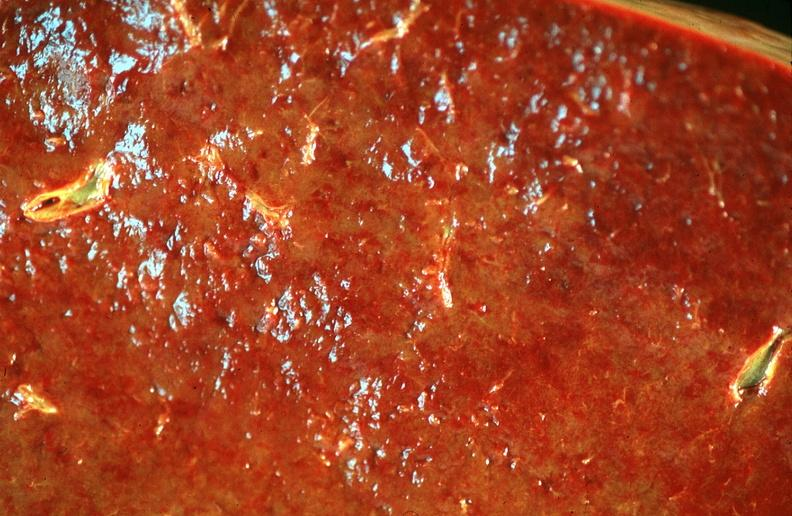s fibrinous peritonitis present?
Answer the question using a single word or phrase. No 